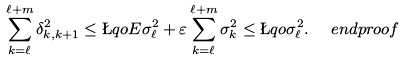Convert formula to latex. <formula><loc_0><loc_0><loc_500><loc_500>\sum _ { k = \ell } ^ { \ell + m } \delta ^ { 2 } _ { k , k + 1 } & \leq \L q o E \sigma _ { \ell } ^ { 2 } + \varepsilon \sum _ { k = \ell } ^ { \ell + m } \sigma _ { k } ^ { 2 } \leq \L q o \sigma _ { \ell } ^ { 2 } . \quad \ e n d p r o o f</formula> 